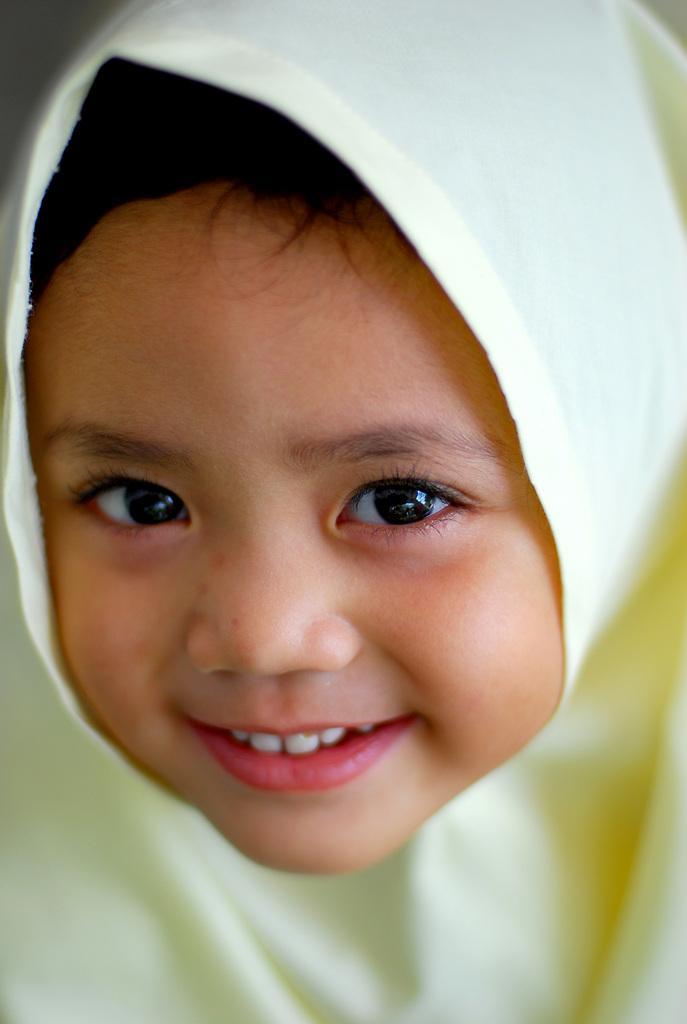In one or two sentences, can you explain what this image depicts? In this picture we can see a kid is smiling. 